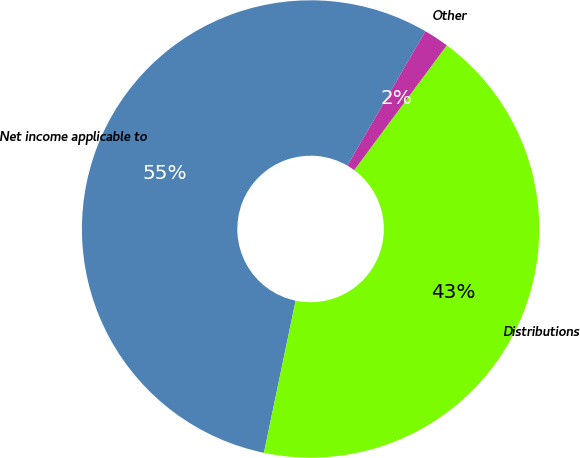Convert chart. <chart><loc_0><loc_0><loc_500><loc_500><pie_chart><fcel>Net income applicable to<fcel>Distributions<fcel>Other<nl><fcel>55.11%<fcel>43.11%<fcel>1.78%<nl></chart> 